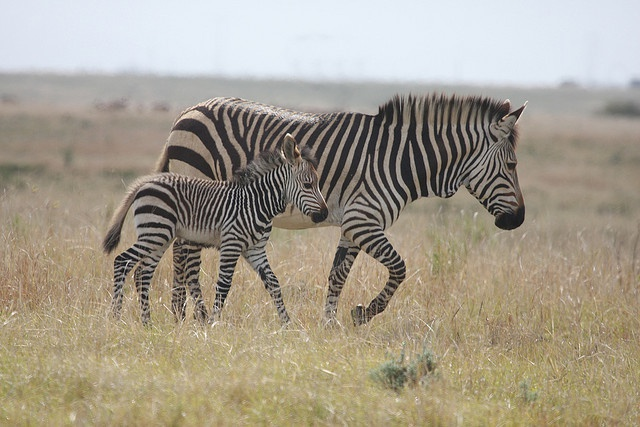Describe the objects in this image and their specific colors. I can see zebra in lavender, black, gray, and darkgray tones and zebra in lavender, gray, black, and darkgray tones in this image. 